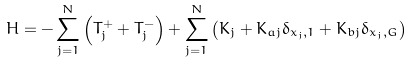Convert formula to latex. <formula><loc_0><loc_0><loc_500><loc_500>H = - \sum _ { j = 1 } ^ { N } \left ( T _ { j } ^ { + } + T _ { j } ^ { - } \right ) + \sum _ { j = 1 } ^ { N } \left ( K _ { j } + K _ { a j } \delta _ { x _ { j } , 1 } + K _ { b j } \delta _ { x _ { j } , G } \right )</formula> 